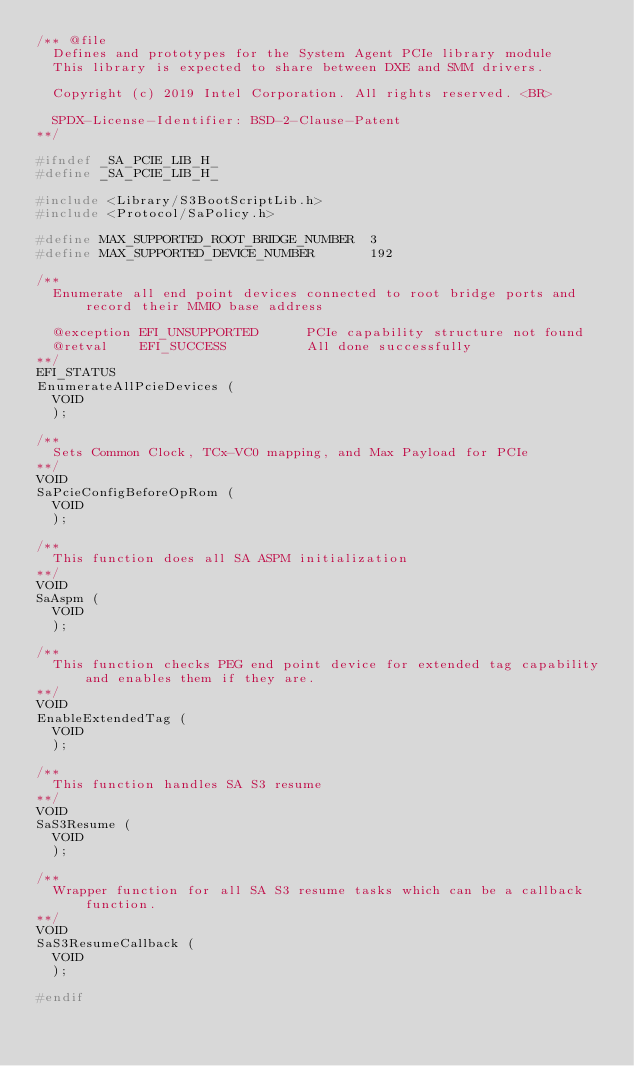Convert code to text. <code><loc_0><loc_0><loc_500><loc_500><_C_>/** @file
  Defines and prototypes for the System Agent PCIe library module
  This library is expected to share between DXE and SMM drivers.

  Copyright (c) 2019 Intel Corporation. All rights reserved. <BR>

  SPDX-License-Identifier: BSD-2-Clause-Patent
**/

#ifndef _SA_PCIE_LIB_H_
#define _SA_PCIE_LIB_H_

#include <Library/S3BootScriptLib.h>
#include <Protocol/SaPolicy.h>

#define MAX_SUPPORTED_ROOT_BRIDGE_NUMBER  3
#define MAX_SUPPORTED_DEVICE_NUMBER       192

/**
  Enumerate all end point devices connected to root bridge ports and record their MMIO base address

  @exception EFI_UNSUPPORTED      PCIe capability structure not found
  @retval    EFI_SUCCESS          All done successfully
**/
EFI_STATUS
EnumerateAllPcieDevices (
  VOID
  );

/**
  Sets Common Clock, TCx-VC0 mapping, and Max Payload for PCIe
**/
VOID
SaPcieConfigBeforeOpRom (
  VOID
  );

/**
  This function does all SA ASPM initialization
**/
VOID
SaAspm (
  VOID
  );

/**
  This function checks PEG end point device for extended tag capability and enables them if they are.
**/
VOID
EnableExtendedTag (
  VOID
  );

/**
  This function handles SA S3 resume
**/
VOID
SaS3Resume (
  VOID
  );

/**
  Wrapper function for all SA S3 resume tasks which can be a callback function.
**/
VOID
SaS3ResumeCallback (
  VOID
  );

#endif
</code> 